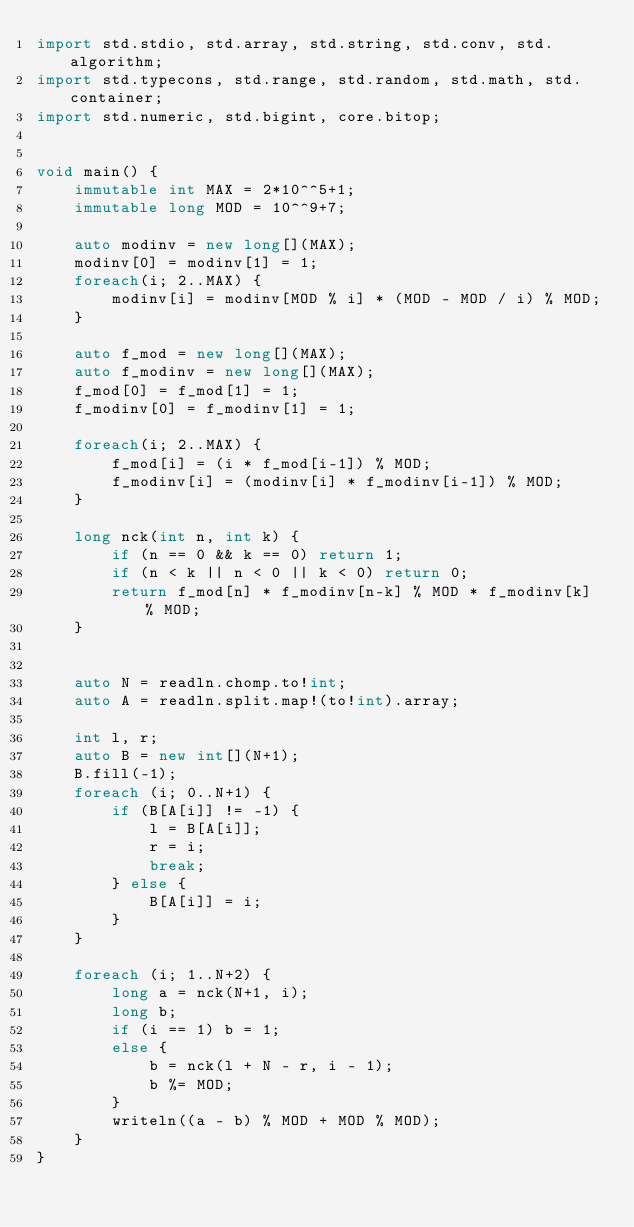<code> <loc_0><loc_0><loc_500><loc_500><_D_>import std.stdio, std.array, std.string, std.conv, std.algorithm;
import std.typecons, std.range, std.random, std.math, std.container;
import std.numeric, std.bigint, core.bitop;


void main() {
    immutable int MAX = 2*10^^5+1;
    immutable long MOD = 10^^9+7;

    auto modinv = new long[](MAX);
    modinv[0] = modinv[1] = 1;
    foreach(i; 2..MAX) {
        modinv[i] = modinv[MOD % i] * (MOD - MOD / i) % MOD;
    }

    auto f_mod = new long[](MAX);
    auto f_modinv = new long[](MAX);
    f_mod[0] = f_mod[1] = 1;
    f_modinv[0] = f_modinv[1] = 1;

    foreach(i; 2..MAX) {
        f_mod[i] = (i * f_mod[i-1]) % MOD;
        f_modinv[i] = (modinv[i] * f_modinv[i-1]) % MOD;
    }

    long nck(int n, int k) {
        if (n == 0 && k == 0) return 1;
        if (n < k || n < 0 || k < 0) return 0;
        return f_mod[n] * f_modinv[n-k] % MOD * f_modinv[k] % MOD;
    }

    
    auto N = readln.chomp.to!int;
    auto A = readln.split.map!(to!int).array;
    
    int l, r;
    auto B = new int[](N+1);
    B.fill(-1);
    foreach (i; 0..N+1) {
        if (B[A[i]] != -1) {
            l = B[A[i]];
            r = i;
            break;
        } else {
            B[A[i]] = i;
        }
    }

    foreach (i; 1..N+2) {
        long a = nck(N+1, i);
        long b;
        if (i == 1) b = 1;
        else {
            b = nck(l + N - r, i - 1);
            b %= MOD;
        }
        writeln((a - b) % MOD + MOD % MOD);
    }
}
</code> 